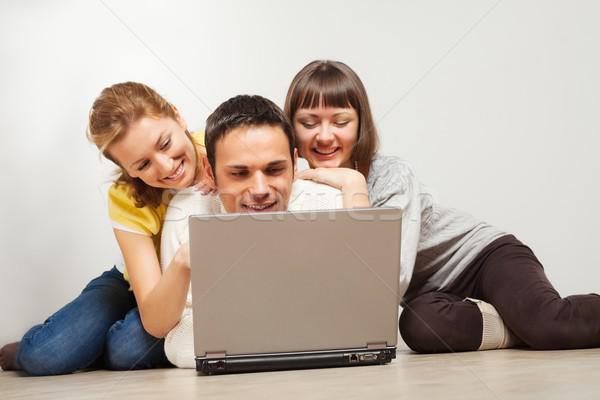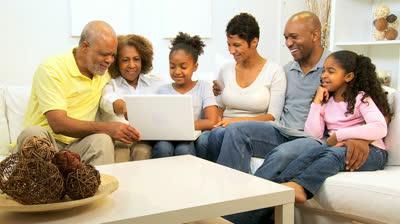The first image is the image on the left, the second image is the image on the right. Considering the images on both sides, is "In one photo, a young child interacts with a laptop and in the other photo, three women look at a single laptop." valid? Answer yes or no. No. The first image is the image on the left, the second image is the image on the right. Given the left and right images, does the statement "One image shows a row of three young women sitting behind one open laptop, and the other image shows a baby boy with a hand on the keyboard of an open laptop." hold true? Answer yes or no. No. 